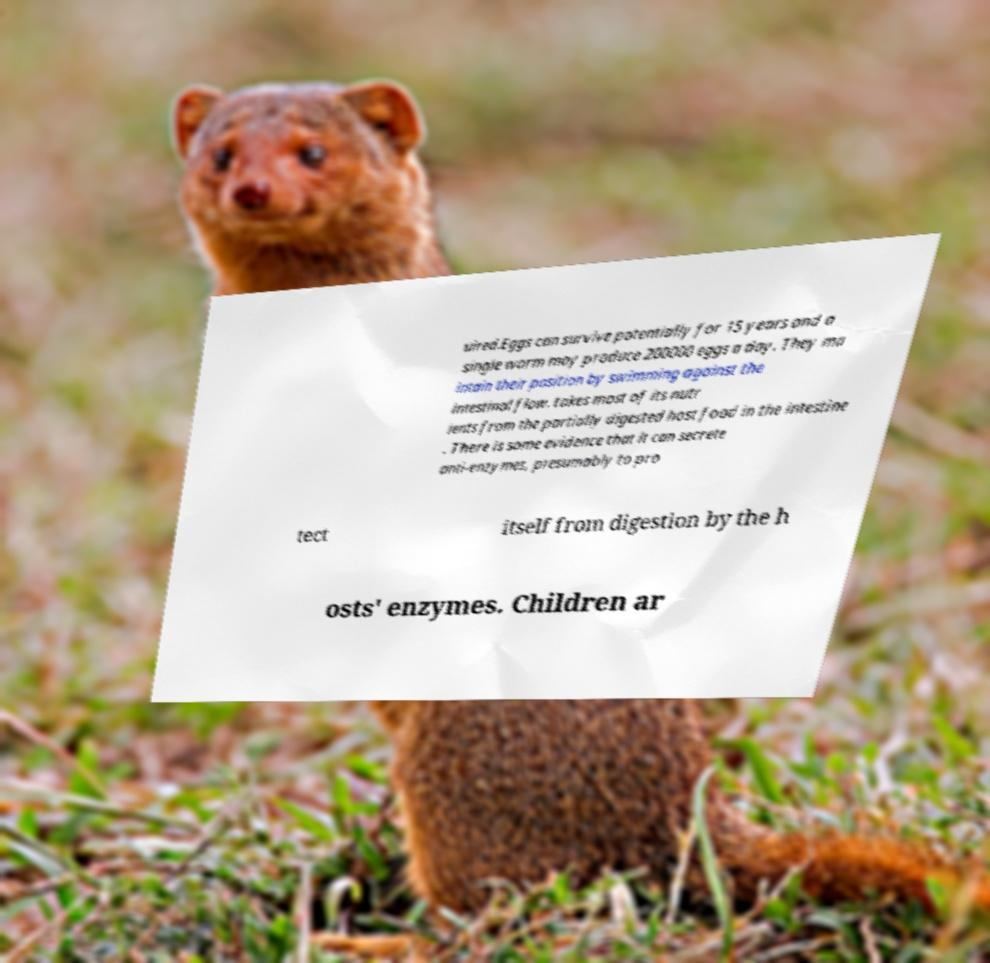Could you assist in decoding the text presented in this image and type it out clearly? uired.Eggs can survive potentially for 15 years and a single worm may produce 200000 eggs a day. They ma intain their position by swimming against the intestinal flow. takes most of its nutr ients from the partially digested host food in the intestine . There is some evidence that it can secrete anti-enzymes, presumably to pro tect itself from digestion by the h osts' enzymes. Children ar 